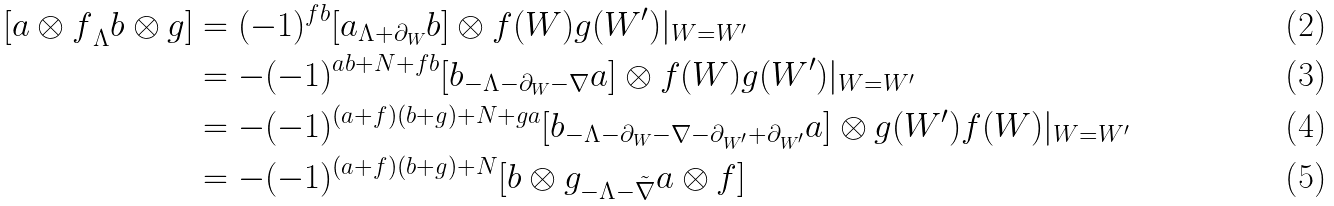<formula> <loc_0><loc_0><loc_500><loc_500>{ [ a \otimes f } _ { \Lambda } b \otimes g ] & = ( - 1 ) ^ { f b } [ a _ { \Lambda + \partial _ { W } } b ] \otimes f ( W ) g ( W ^ { \prime } ) | _ { W = W ^ { \prime } } \\ & = - ( - 1 ) ^ { a b + N + f b } [ b _ { - \Lambda - \partial _ { W } - \nabla } a ] \otimes f ( W ) g ( W ^ { \prime } ) | _ { W = W ^ { \prime } } \\ & = - ( - 1 ) ^ { ( a + f ) ( b + g ) + N + g a } [ b _ { - \Lambda - \partial _ { W } - \nabla - \partial _ { W ^ { \prime } } + \partial _ { W ^ { \prime } } } a ] \otimes g ( W ^ { \prime } ) f ( W ) | _ { W = W ^ { \prime } } \\ & = - ( - 1 ) ^ { ( a + f ) ( b + g ) + N } [ b \otimes g _ { - \Lambda - \tilde { \nabla } } a \otimes f ]</formula> 